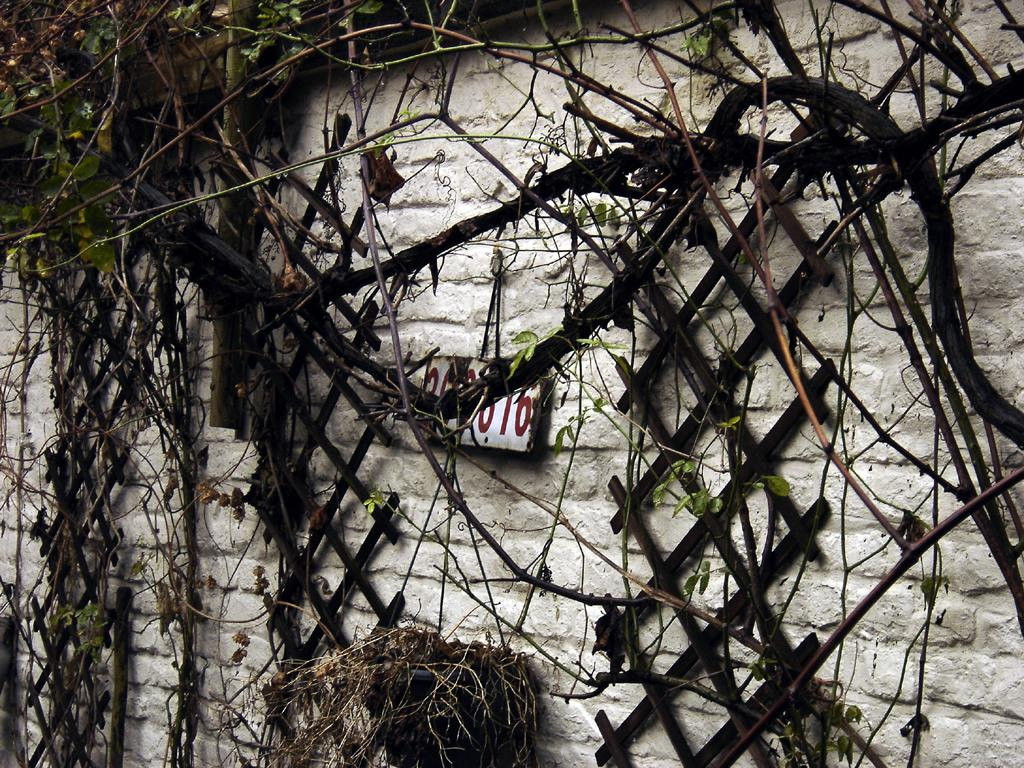What is present on the wall in the image? There is a wall in the image with wooden frames, a board with numbers, and creepers and stems on it. Can you describe the wooden frames on the wall? The wooden frames are present on the wall, but their specific details are not mentioned in the facts. What is hanging on the wall? A board with numbers is hanging on the wall. What type of vegetation is growing on the wall? Creepers and stems are growing on the wall. What type of oatmeal is being served in the image? There is no oatmeal present in the image; it only features a wall with wooden frames, a board with numbers, and creepers and stems. 